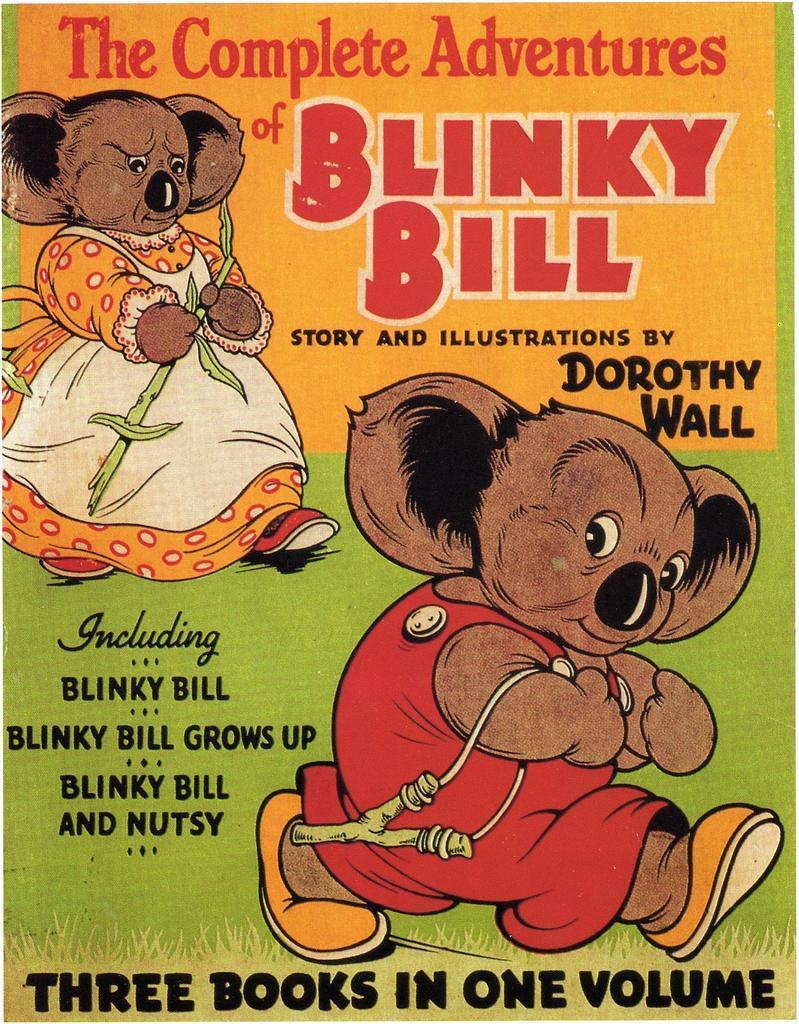Can you describe this image briefly? In this image I can see the cover page of the book. On the book I can see the toys with dresses and something is written on it. And the book is colorful. 